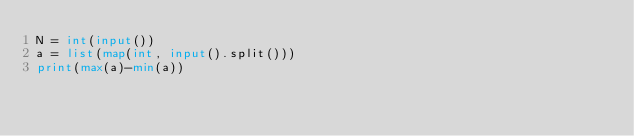Convert code to text. <code><loc_0><loc_0><loc_500><loc_500><_Python_>N = int(input())
a = list(map(int, input().split()))
print(max(a)-min(a))</code> 